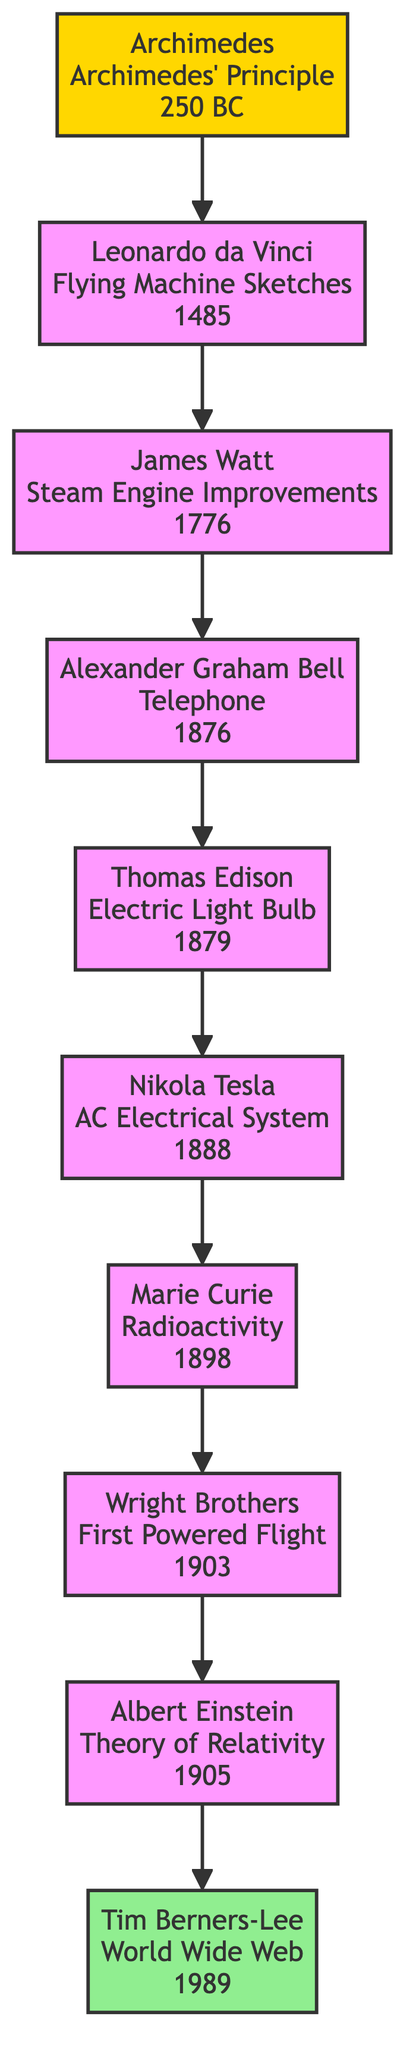What is the breakthrough of Nikola Tesla? The diagram shows a node for Nikola Tesla with the label "AC Electrical System" indicating his breakthrough.
Answer: AC Electrical System Who invented the telephone? The diagram presents a connection from Alexander Graham Bell's node to his breakthrough labeled "Telephone," making it clear that he is the inventor.
Answer: Alexander Graham Bell How many inventors are shown in the diagram? By counting the nodes, we find there are a total of 10 inventors displayed in the diagram.
Answer: 10 Which inventor is linked to Marie Curie? Moving up the diagram from Marie Curie's node, we see that she is connected to Nikola Tesla's node, indicating that Tesla is linked to her.
Answer: Nikola Tesla What breakthrough is linked to James Watt? In the diagram, James Watt's node is connected to Alexander Graham Bell's node, indicating the flow of inventions where Bell's breakthrough follows Watt's improvements.
Answer: Steam Engine Improvements Who is the last inventor in the lineage? The last node in the lineage, moving down the diagram, is Tim Berners-Lee which indicates he is the latest inventor in the sequence of breakthroughs.
Answer: Tim Berners-Lee What year did Thomas Edison invent the Electric Light Bulb? The node for Thomas Edison provides the year directly in the diagram as 1879, indicating the time of his breakthrough.
Answer: 1879 Which invention came first, the Telephone or the Electric Light Bulb? The diagram shows that the node for Alexander Graham Bell's Telephone (1876) is positioned before the node for Thomas Edison's Electric Light Bulb (1879) indicating that the Telephone came first.
Answer: Telephone What is the relationship between Archimedes and Leonardo da Vinci in the diagram? Following the connections in the family tree, Archimedes is the ancestor of Leonardo da Vinci, indicating a direct lineage.
Answer: Ancestor-descendant 